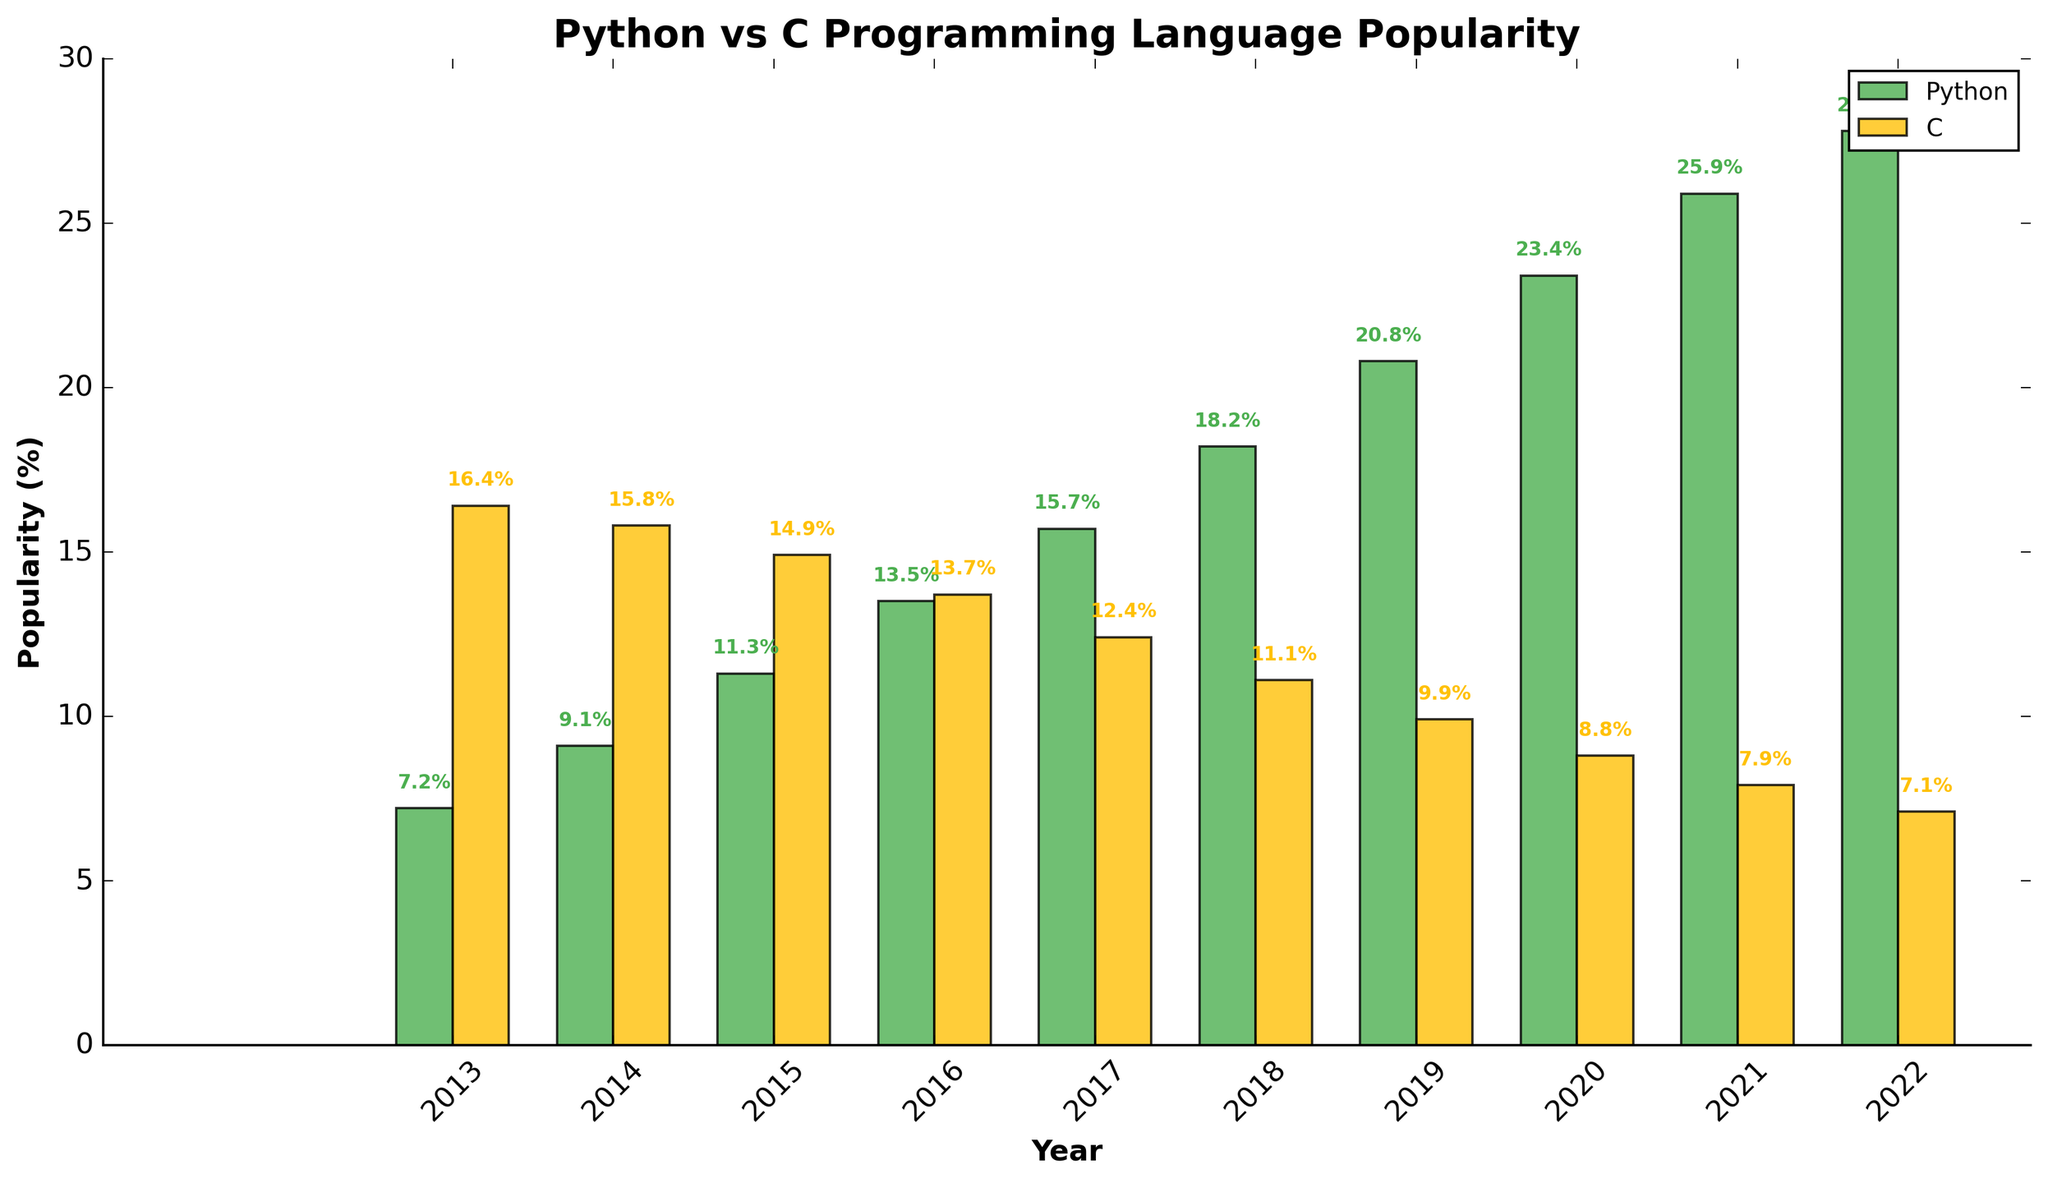What trends can be observed in the popularity of Python and C from 2013 to 2022? From 2013 to 2022, the popularity of Python shows a steady increase, rising from 7.2% to 27.8%. Conversely, the popularity of C shows a consistent decline from 16.4% to 7.1%.
Answer: Python: increase, C: decrease In which year did Python's popularity first surpass 20%? By observing the heights of the bars representing Python's popularity, it is evident that Python first surpasses the 20% mark in 2019 with a value of 20.8%.
Answer: 2019 In which year did C experience the most significant decline in popularity? Examining the data, C's popularity dropped from 11.1% in 2018 to 9.9% in 2019, a decline of 1.2%. This is the largest year-to-year decrease.
Answer: 2019 Calculate the average popularity of Python over the decade. Summing up the Python values (7.2 + 9.1 + 11.3 + 13.5 + 15.7 + 18.2 + 20.8 + 23.4 + 25.9 + 27.8) = 172.9, then dividing by the number of years (10) gives the average: 172.9 / 10 = 17.29.
Answer: 17.29% How does the popularity of Python in 2013 compare to C's popularity in 2022? The bar height for Python in 2013 is 7.2%, and for C in 2022, it is 7.1%. Python was slightly more popular in 2013 than C was in 2022.
Answer: Python in 2013 > C in 2022 Which programming language had the highest popularity in a single year across the decade? Observing the maximum height of any single bar across all years, Python in 2022 has the highest popularity at 27.8%.
Answer: Python in 2022 Between which years did Python see the largest increase in popularity? The largest increase for Python happened between 2019 (20.8%) and 2020 (23.4%), an increase of 2.6 percentage points.
Answer: 2019-2020 Compare the overall trends of Python and C from 2016 to 2022. From 2016 to 2022, Python's popularity steadily increased from 13.5% to 27.8%. C, on the other hand, saw a decline from 13.7% to 7.1%.
Answer: Python: increased, C: decreased 